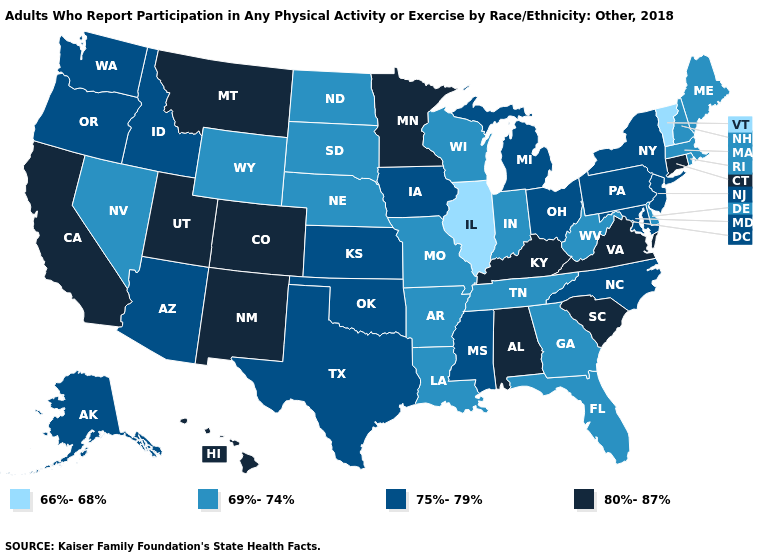Which states have the lowest value in the Northeast?
Answer briefly. Vermont. Does the map have missing data?
Write a very short answer. No. What is the value of Illinois?
Be succinct. 66%-68%. What is the value of Tennessee?
Keep it brief. 69%-74%. Among the states that border Texas , does Arkansas have the lowest value?
Be succinct. Yes. What is the value of North Carolina?
Give a very brief answer. 75%-79%. What is the highest value in the South ?
Quick response, please. 80%-87%. What is the value of Virginia?
Keep it brief. 80%-87%. Among the states that border West Virginia , does Virginia have the lowest value?
Answer briefly. No. Name the states that have a value in the range 75%-79%?
Short answer required. Alaska, Arizona, Idaho, Iowa, Kansas, Maryland, Michigan, Mississippi, New Jersey, New York, North Carolina, Ohio, Oklahoma, Oregon, Pennsylvania, Texas, Washington. Among the states that border Colorado , does Kansas have the highest value?
Answer briefly. No. Name the states that have a value in the range 80%-87%?
Concise answer only. Alabama, California, Colorado, Connecticut, Hawaii, Kentucky, Minnesota, Montana, New Mexico, South Carolina, Utah, Virginia. What is the value of South Carolina?
Write a very short answer. 80%-87%. What is the value of North Dakota?
Answer briefly. 69%-74%. Which states hav the highest value in the Northeast?
Write a very short answer. Connecticut. 